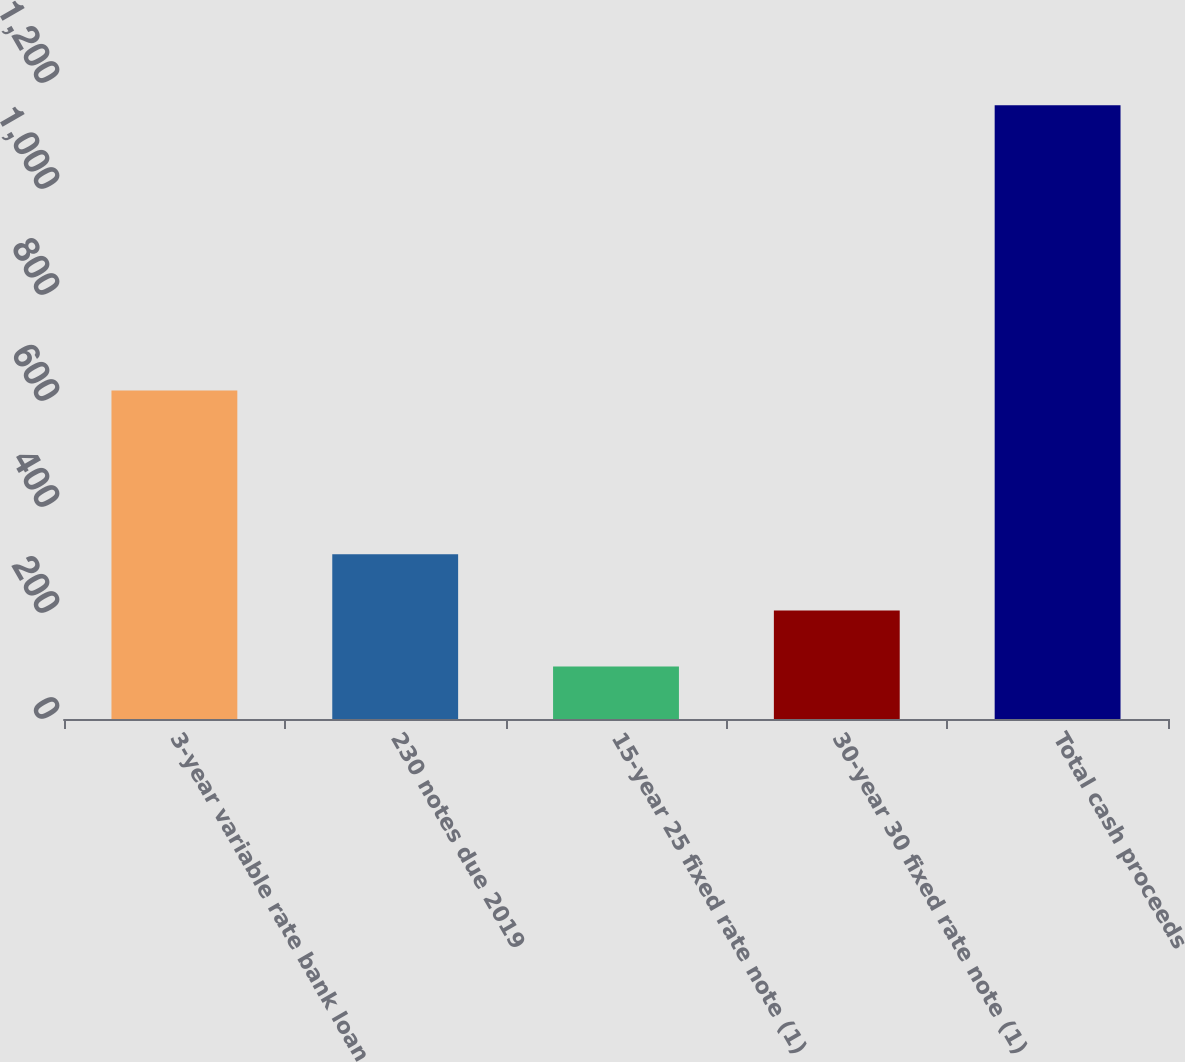Convert chart. <chart><loc_0><loc_0><loc_500><loc_500><bar_chart><fcel>3-year variable rate bank loan<fcel>230 notes due 2019<fcel>15-year 25 fixed rate note (1)<fcel>30-year 30 fixed rate note (1)<fcel>Total cash proceeds<nl><fcel>620<fcel>310.8<fcel>99<fcel>204.9<fcel>1158<nl></chart> 